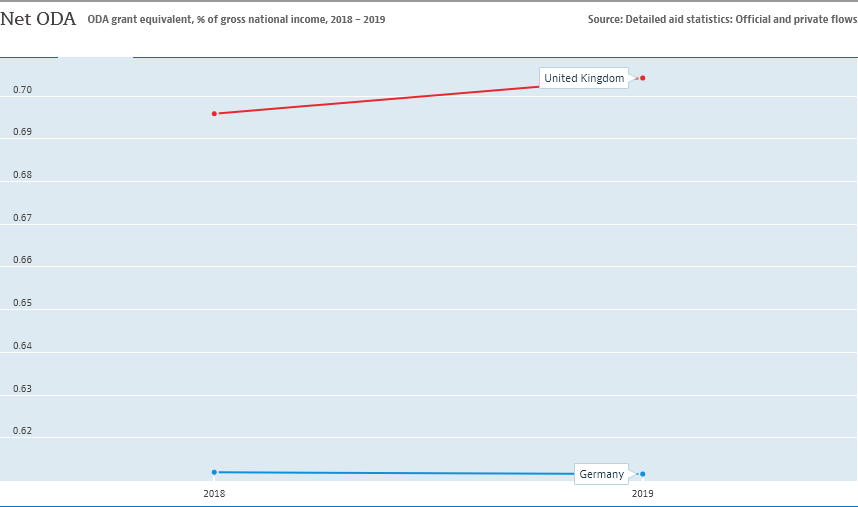Indicate a few pertinent items in this graphic. In 2019, the United Kingdom received the largest amount of official development assistance (ODA) in its history. Germany is represented by the blue color line. 